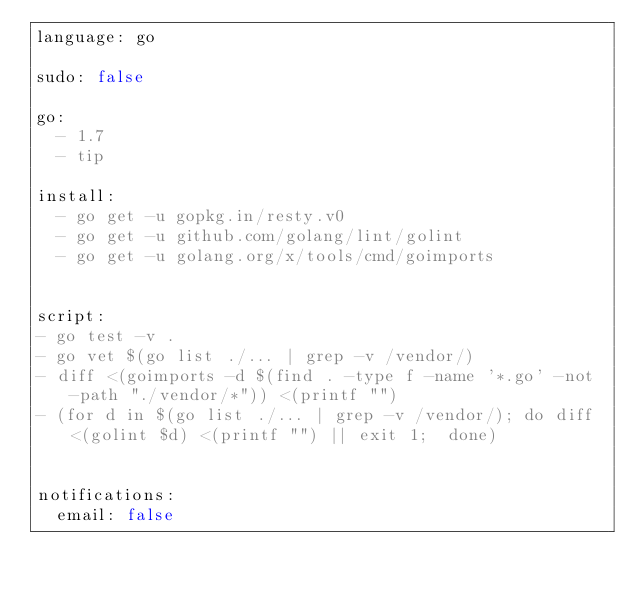Convert code to text. <code><loc_0><loc_0><loc_500><loc_500><_YAML_>language: go

sudo: false

go:
  - 1.7
  - tip

install:
  - go get -u gopkg.in/resty.v0
  - go get -u github.com/golang/lint/golint
  - go get -u golang.org/x/tools/cmd/goimports


script:
- go test -v .
- go vet $(go list ./... | grep -v /vendor/)
- diff <(goimports -d $(find . -type f -name '*.go' -not -path "./vendor/*")) <(printf "")
- (for d in $(go list ./... | grep -v /vendor/); do diff <(golint $d) <(printf "") || exit 1;  done)


notifications:
  email: false
</code> 